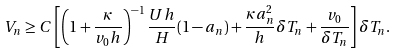Convert formula to latex. <formula><loc_0><loc_0><loc_500><loc_500>V _ { n } \geq C \left [ \left ( 1 + \frac { \kappa } { v _ { 0 } h } \right ) ^ { - 1 } \frac { U h } { H } ( 1 - a _ { n } ) + \frac { \kappa a _ { n } ^ { 2 } } { h } \delta T _ { n } + \frac { v _ { 0 } } { \delta T _ { n } } \right ] \delta T _ { n } .</formula> 